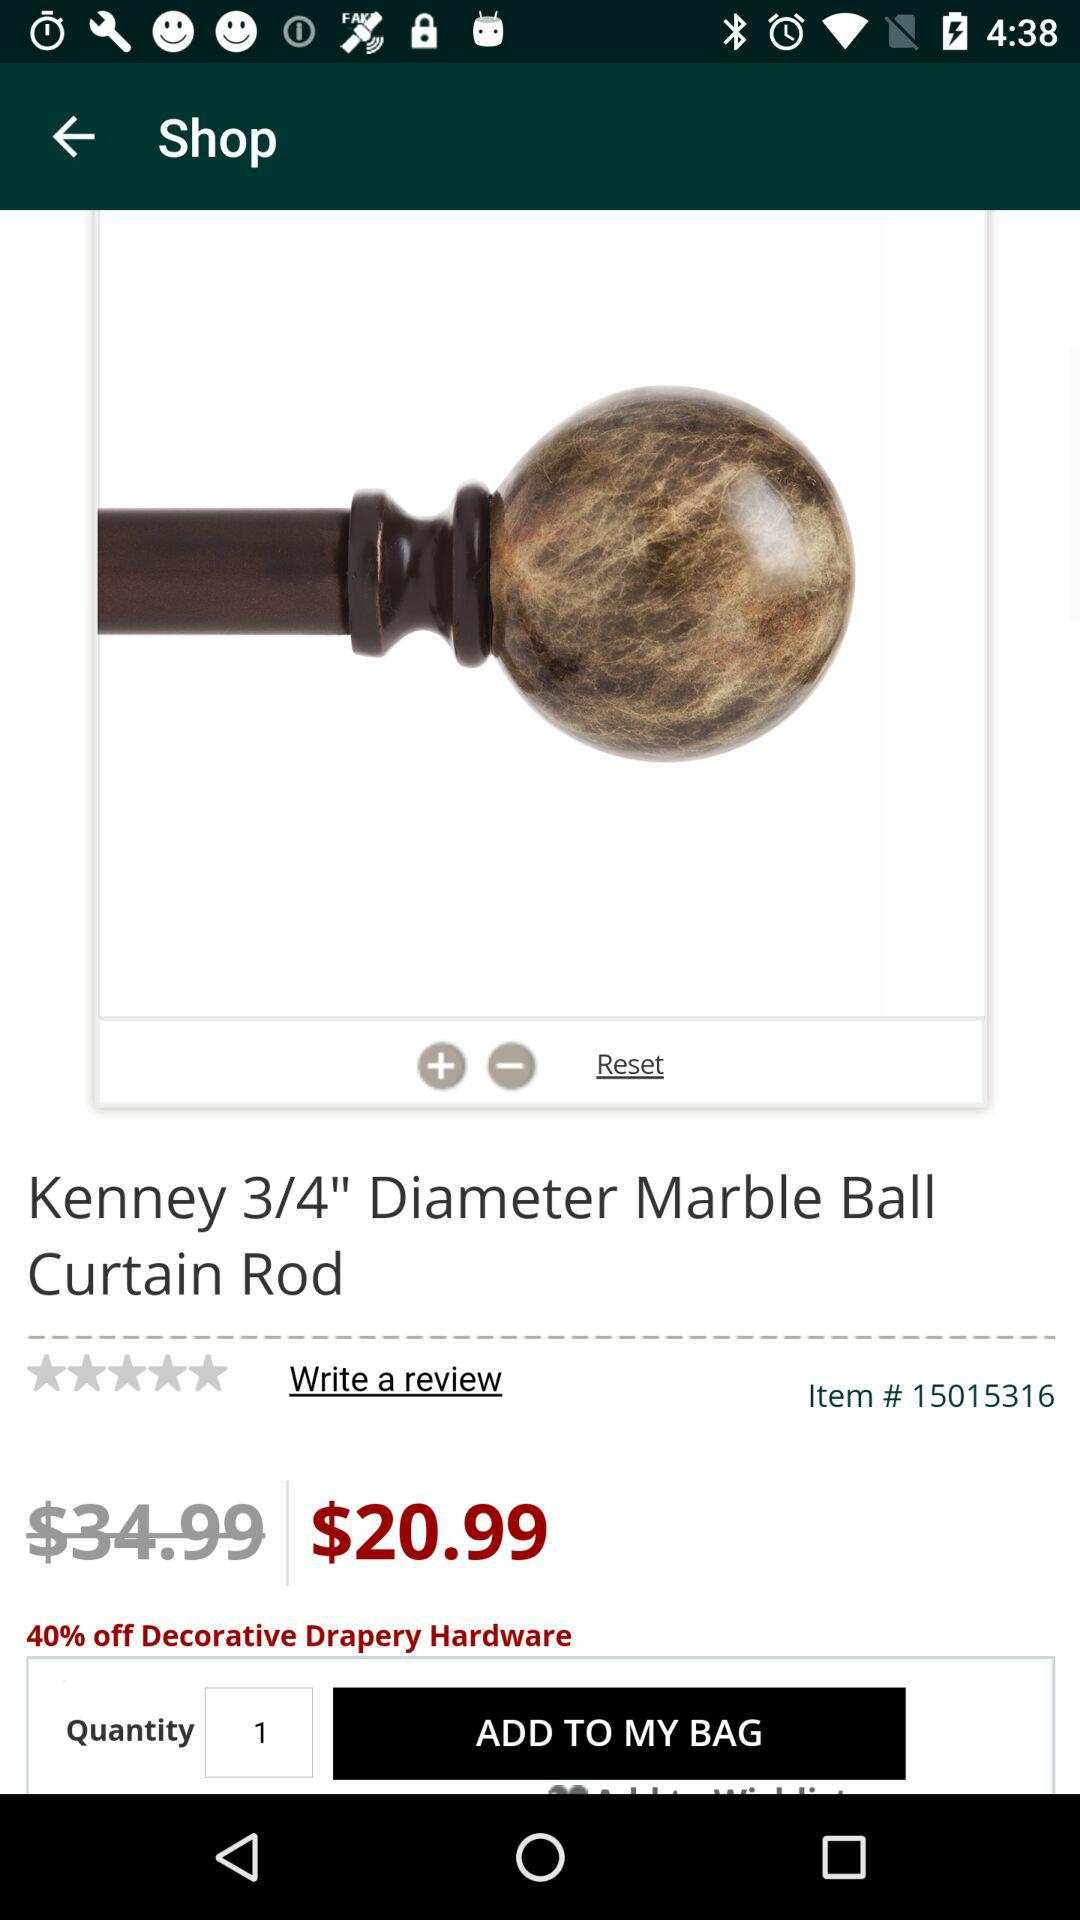What is the original price of the item?
Answer the question using a single word or phrase. $34.99 